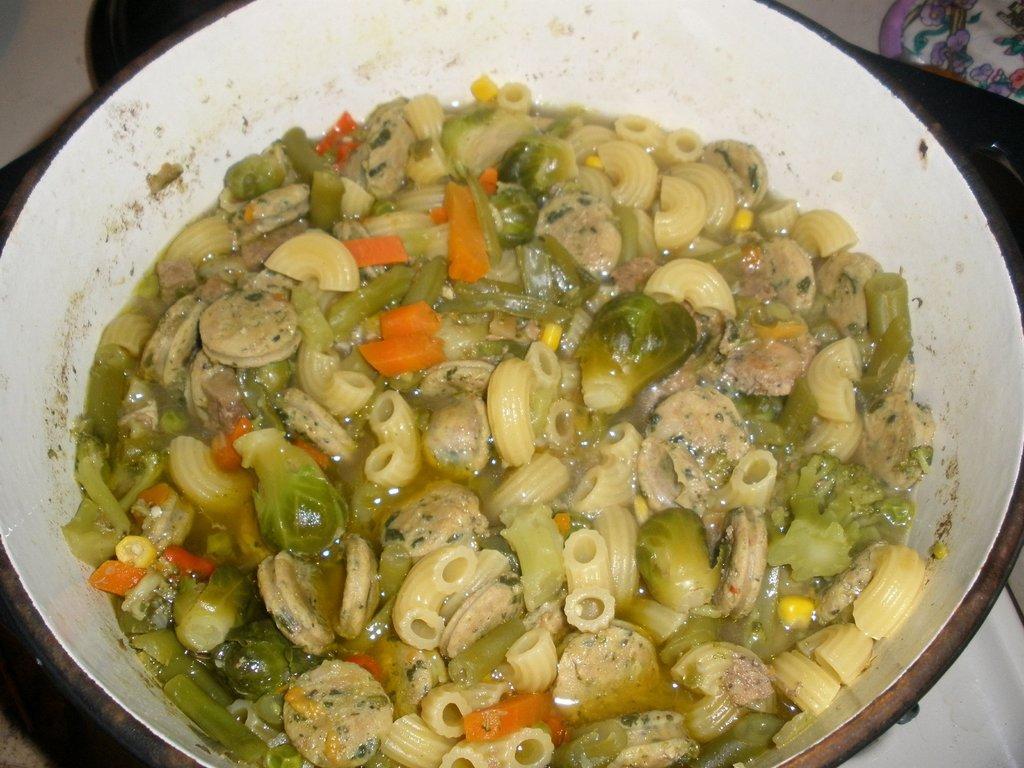Can you describe this image briefly? In this image I can see a white colored plate in which I can see a food item which is cream, orange, green and yellow in color. In the background I can see few other objects. 